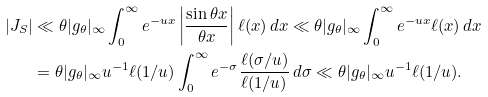<formula> <loc_0><loc_0><loc_500><loc_500>| J _ { S } | & \ll \theta | g _ { \theta } | _ { \infty } \int _ { 0 } ^ { \infty } e ^ { - u x } \left | \frac { \sin \theta x } { \theta x } \right | \ell ( x ) \, d x \ll \theta | g _ { \theta } | _ { \infty } \int _ { 0 } ^ { \infty } e ^ { - u x } \ell ( x ) \, d x \\ & = \theta | g _ { \theta } | _ { \infty } u ^ { - 1 } \ell ( 1 / u ) \int _ { 0 } ^ { \infty } e ^ { - \sigma } \frac { \ell ( \sigma / u ) } { \ell ( 1 / u ) } \, d \sigma \ll \theta | g _ { \theta } | _ { \infty } u ^ { - 1 } \ell ( 1 / u ) .</formula> 